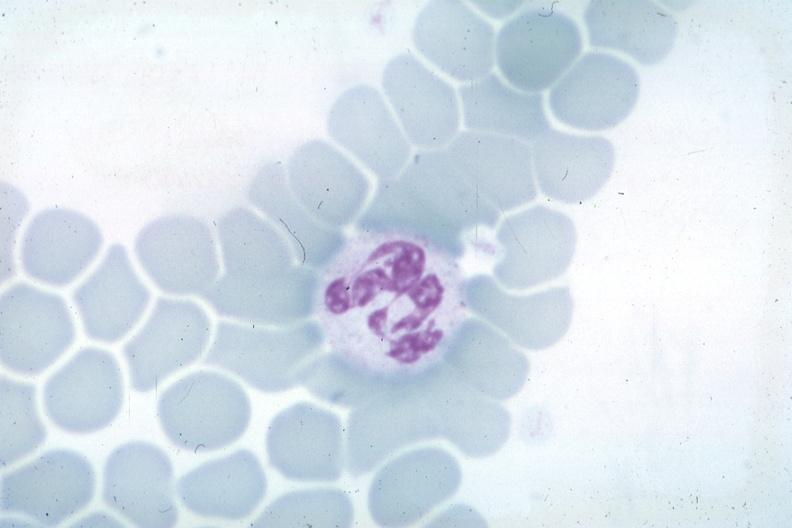what is obvious source unknown?
Answer the question using a single word or phrase. Nuclear change 